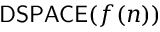Convert formula to latex. <formula><loc_0><loc_0><loc_500><loc_500>{ D S P A C E } ( f ( n ) )</formula> 